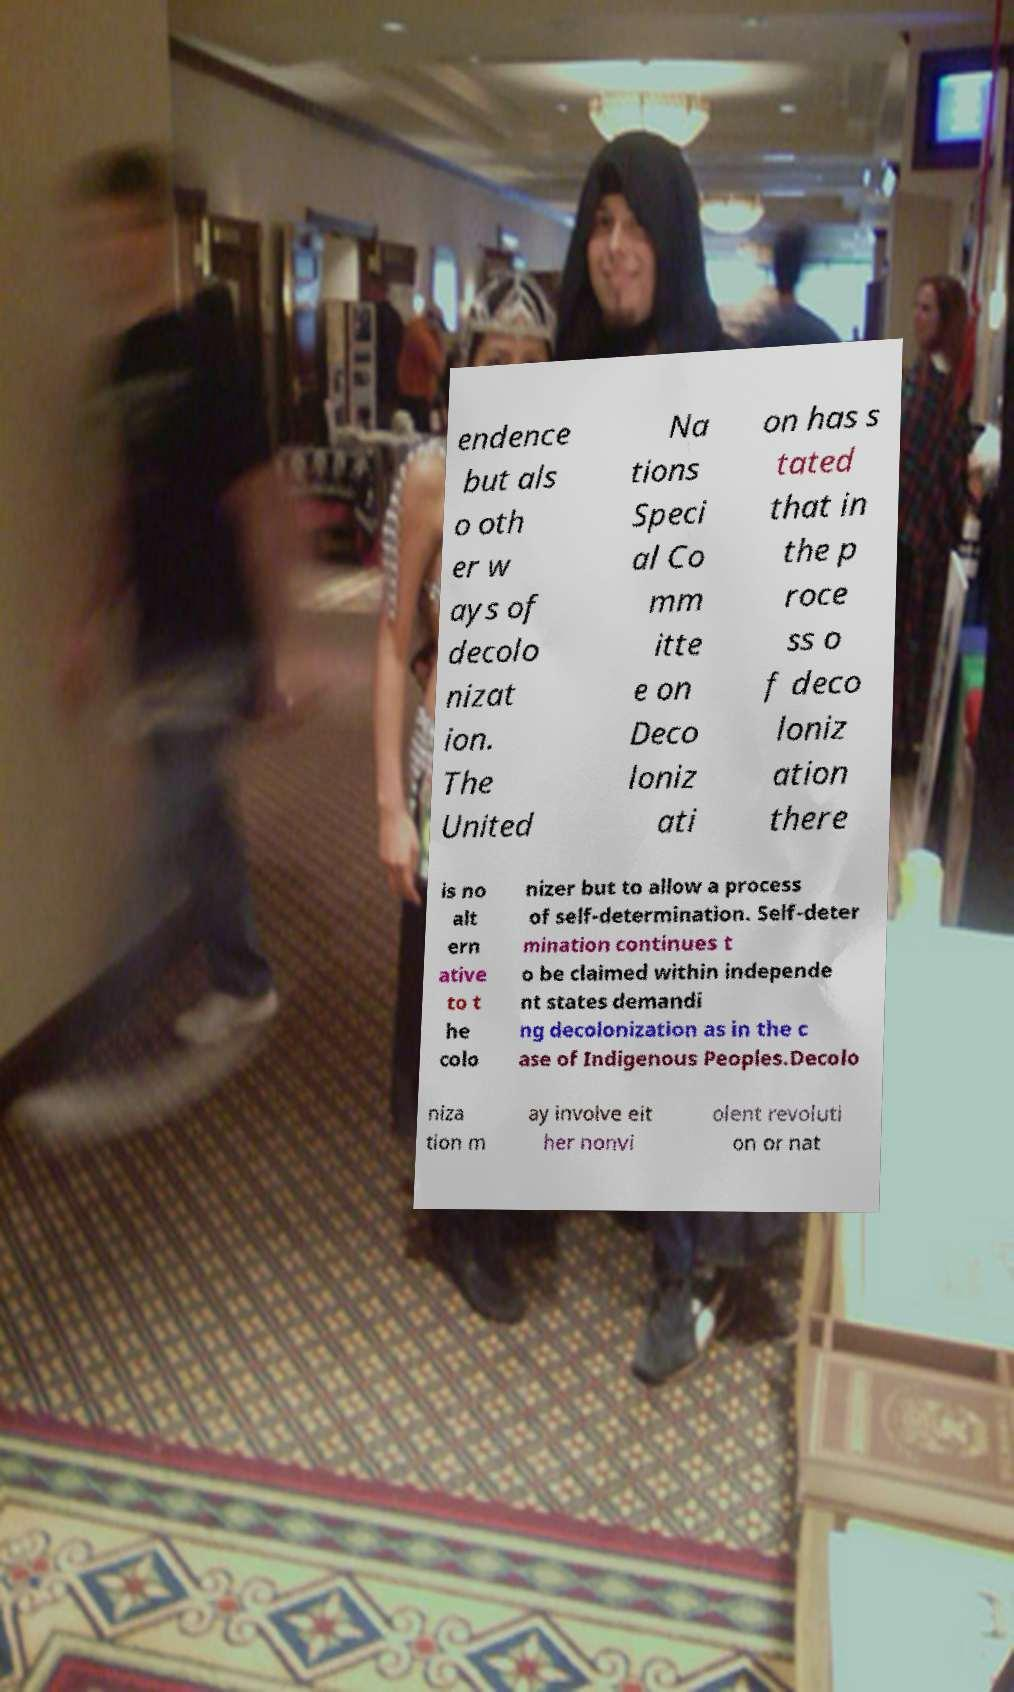Please identify and transcribe the text found in this image. endence but als o oth er w ays of decolo nizat ion. The United Na tions Speci al Co mm itte e on Deco loniz ati on has s tated that in the p roce ss o f deco loniz ation there is no alt ern ative to t he colo nizer but to allow a process of self-determination. Self-deter mination continues t o be claimed within independe nt states demandi ng decolonization as in the c ase of Indigenous Peoples.Decolo niza tion m ay involve eit her nonvi olent revoluti on or nat 